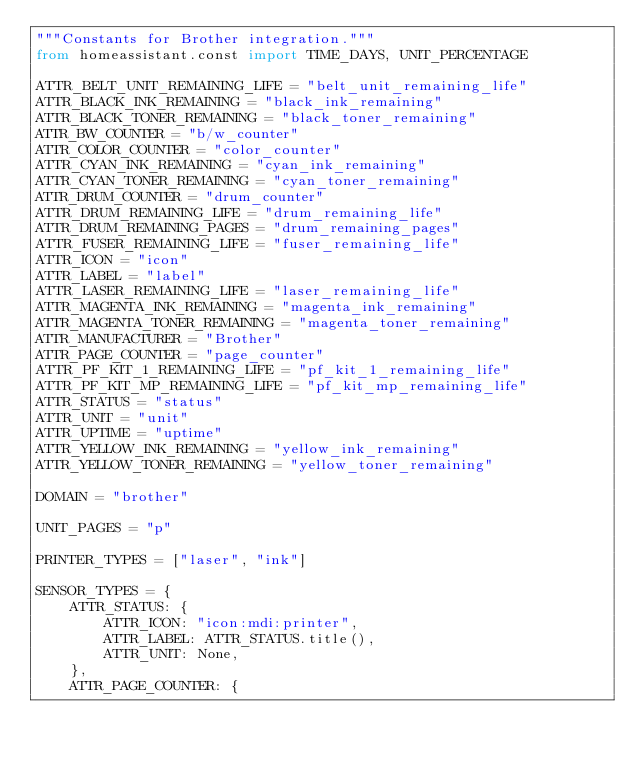<code> <loc_0><loc_0><loc_500><loc_500><_Python_>"""Constants for Brother integration."""
from homeassistant.const import TIME_DAYS, UNIT_PERCENTAGE

ATTR_BELT_UNIT_REMAINING_LIFE = "belt_unit_remaining_life"
ATTR_BLACK_INK_REMAINING = "black_ink_remaining"
ATTR_BLACK_TONER_REMAINING = "black_toner_remaining"
ATTR_BW_COUNTER = "b/w_counter"
ATTR_COLOR_COUNTER = "color_counter"
ATTR_CYAN_INK_REMAINING = "cyan_ink_remaining"
ATTR_CYAN_TONER_REMAINING = "cyan_toner_remaining"
ATTR_DRUM_COUNTER = "drum_counter"
ATTR_DRUM_REMAINING_LIFE = "drum_remaining_life"
ATTR_DRUM_REMAINING_PAGES = "drum_remaining_pages"
ATTR_FUSER_REMAINING_LIFE = "fuser_remaining_life"
ATTR_ICON = "icon"
ATTR_LABEL = "label"
ATTR_LASER_REMAINING_LIFE = "laser_remaining_life"
ATTR_MAGENTA_INK_REMAINING = "magenta_ink_remaining"
ATTR_MAGENTA_TONER_REMAINING = "magenta_toner_remaining"
ATTR_MANUFACTURER = "Brother"
ATTR_PAGE_COUNTER = "page_counter"
ATTR_PF_KIT_1_REMAINING_LIFE = "pf_kit_1_remaining_life"
ATTR_PF_KIT_MP_REMAINING_LIFE = "pf_kit_mp_remaining_life"
ATTR_STATUS = "status"
ATTR_UNIT = "unit"
ATTR_UPTIME = "uptime"
ATTR_YELLOW_INK_REMAINING = "yellow_ink_remaining"
ATTR_YELLOW_TONER_REMAINING = "yellow_toner_remaining"

DOMAIN = "brother"

UNIT_PAGES = "p"

PRINTER_TYPES = ["laser", "ink"]

SENSOR_TYPES = {
    ATTR_STATUS: {
        ATTR_ICON: "icon:mdi:printer",
        ATTR_LABEL: ATTR_STATUS.title(),
        ATTR_UNIT: None,
    },
    ATTR_PAGE_COUNTER: {</code> 